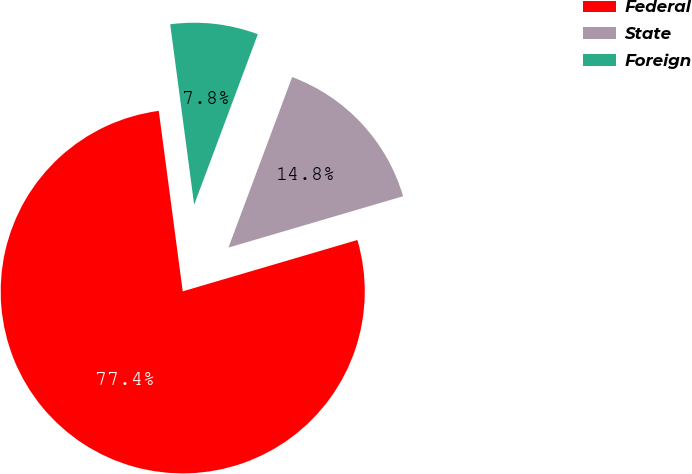Convert chart to OTSL. <chart><loc_0><loc_0><loc_500><loc_500><pie_chart><fcel>Federal<fcel>State<fcel>Foreign<nl><fcel>77.45%<fcel>14.76%<fcel>7.79%<nl></chart> 